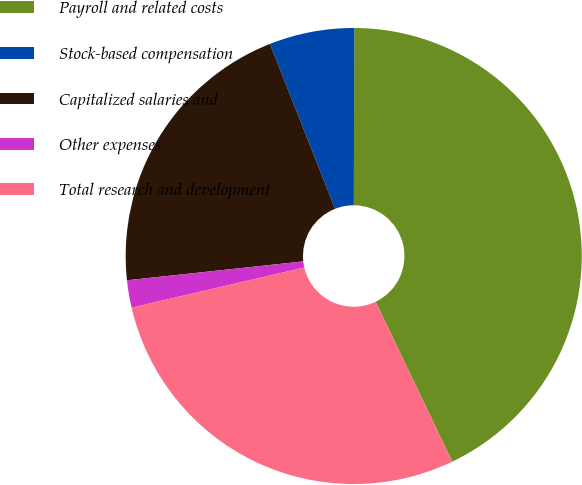<chart> <loc_0><loc_0><loc_500><loc_500><pie_chart><fcel>Payroll and related costs<fcel>Stock-based compensation<fcel>Capitalized salaries and<fcel>Other expenses<fcel>Total research and development<nl><fcel>42.85%<fcel>6.03%<fcel>20.71%<fcel>1.94%<fcel>28.48%<nl></chart> 